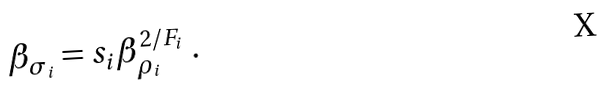Convert formula to latex. <formula><loc_0><loc_0><loc_500><loc_500>\beta _ { \sigma _ { i } } = s _ { i } \beta _ { \rho _ { i } } ^ { 2 / F _ { i } } \ .</formula> 